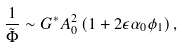<formula> <loc_0><loc_0><loc_500><loc_500>\frac { 1 } { \tilde { \Phi } } \sim G ^ { * } A _ { 0 } ^ { 2 } \left ( 1 + 2 \epsilon \alpha _ { 0 } \phi _ { 1 } \right ) ,</formula> 